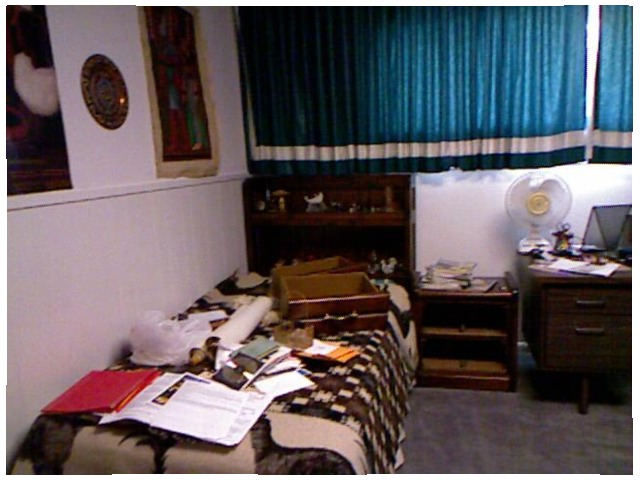<image>
Can you confirm if the drawer is on the bed? Yes. Looking at the image, I can see the drawer is positioned on top of the bed, with the bed providing support. Where is the fan in relation to the bed? Is it in the bed? No. The fan is not contained within the bed. These objects have a different spatial relationship. 